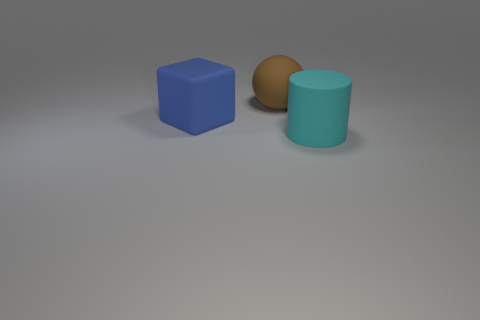Subtract all blocks. How many objects are left? 2 Add 2 big red balls. How many objects exist? 5 Subtract all purple spheres. Subtract all gray blocks. How many spheres are left? 1 Subtract all large purple matte spheres. Subtract all big brown matte objects. How many objects are left? 2 Add 1 brown balls. How many brown balls are left? 2 Add 1 big blue rubber spheres. How many big blue rubber spheres exist? 1 Subtract 0 gray balls. How many objects are left? 3 Subtract 1 spheres. How many spheres are left? 0 